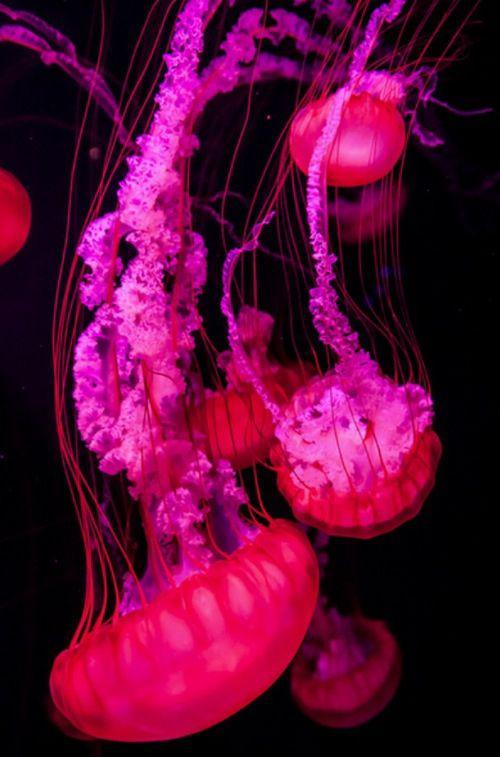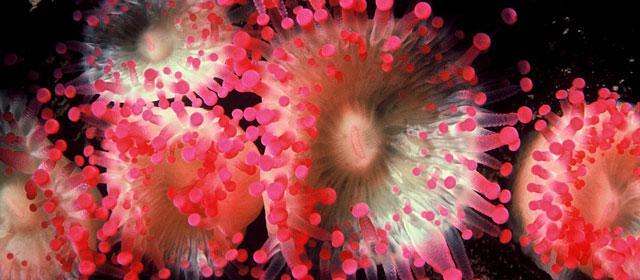The first image is the image on the left, the second image is the image on the right. Assess this claim about the two images: "The left image shows at least one hot pink jellyfish trailing tendrils.". Correct or not? Answer yes or no. Yes. The first image is the image on the left, the second image is the image on the right. Evaluate the accuracy of this statement regarding the images: "The pink jellyfish in the image on the left is against a black background.". Is it true? Answer yes or no. Yes. 